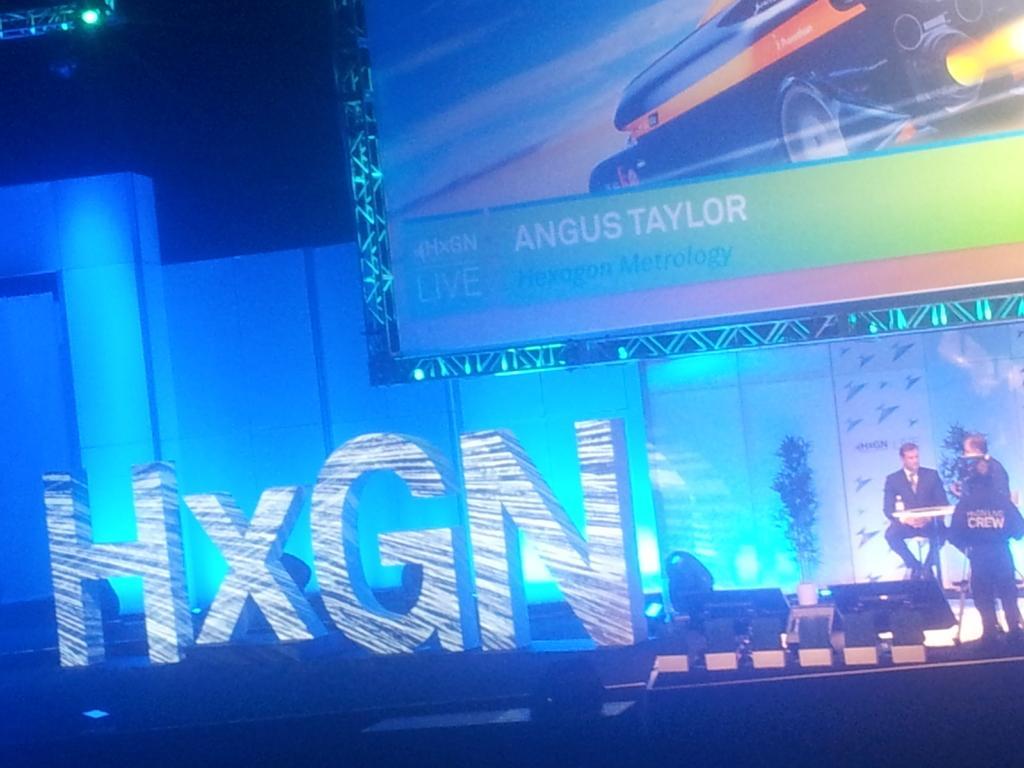In one or two sentences, can you explain what this image depicts? In this image on the right side there are two persons, and in the center there is a text. At the bottom it looks like a stage, and in the background there is screen and some lights. On the screen there is text, and at the top of the left corner there is one tower. 